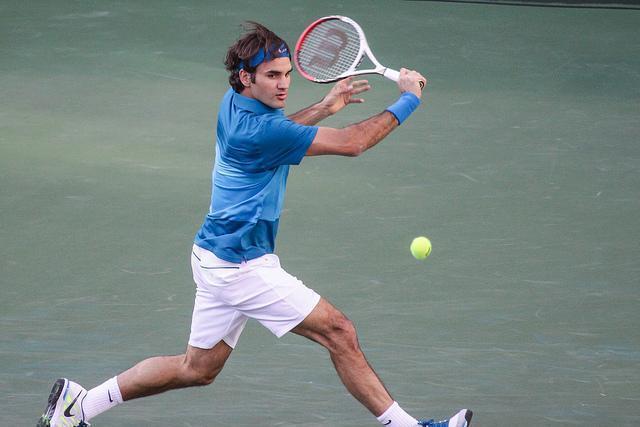How many zebras are there?
Give a very brief answer. 0. 